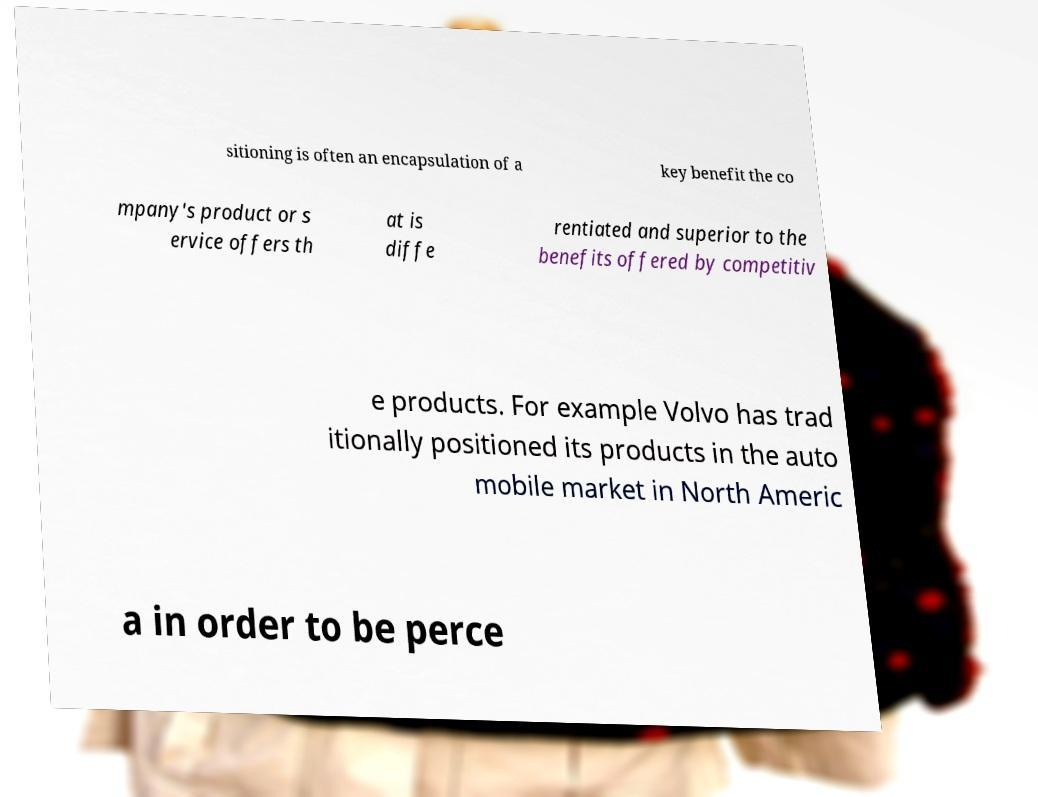Can you accurately transcribe the text from the provided image for me? sitioning is often an encapsulation of a key benefit the co mpany's product or s ervice offers th at is diffe rentiated and superior to the benefits offered by competitiv e products. For example Volvo has trad itionally positioned its products in the auto mobile market in North Americ a in order to be perce 